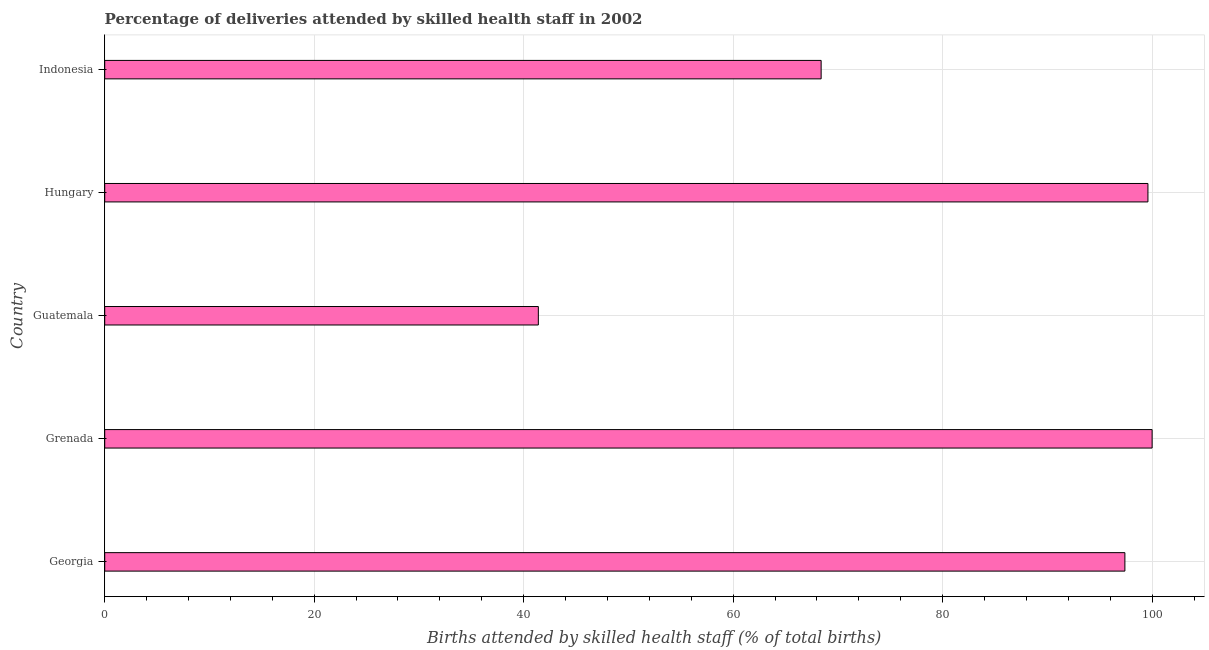Does the graph contain any zero values?
Ensure brevity in your answer.  No. What is the title of the graph?
Provide a succinct answer. Percentage of deliveries attended by skilled health staff in 2002. What is the label or title of the X-axis?
Make the answer very short. Births attended by skilled health staff (% of total births). What is the label or title of the Y-axis?
Provide a short and direct response. Country. What is the number of births attended by skilled health staff in Hungary?
Ensure brevity in your answer.  99.6. Across all countries, what is the maximum number of births attended by skilled health staff?
Offer a terse response. 100. Across all countries, what is the minimum number of births attended by skilled health staff?
Give a very brief answer. 41.4. In which country was the number of births attended by skilled health staff maximum?
Your answer should be compact. Grenada. In which country was the number of births attended by skilled health staff minimum?
Offer a very short reply. Guatemala. What is the sum of the number of births attended by skilled health staff?
Your answer should be compact. 406.8. What is the difference between the number of births attended by skilled health staff in Guatemala and Hungary?
Offer a very short reply. -58.2. What is the average number of births attended by skilled health staff per country?
Make the answer very short. 81.36. What is the median number of births attended by skilled health staff?
Provide a short and direct response. 97.4. In how many countries, is the number of births attended by skilled health staff greater than 28 %?
Provide a succinct answer. 5. What is the ratio of the number of births attended by skilled health staff in Grenada to that in Guatemala?
Ensure brevity in your answer.  2.42. Is the number of births attended by skilled health staff in Georgia less than that in Hungary?
Your response must be concise. Yes. Is the difference between the number of births attended by skilled health staff in Guatemala and Indonesia greater than the difference between any two countries?
Your response must be concise. No. What is the difference between the highest and the second highest number of births attended by skilled health staff?
Ensure brevity in your answer.  0.4. What is the difference between the highest and the lowest number of births attended by skilled health staff?
Provide a short and direct response. 58.6. Are the values on the major ticks of X-axis written in scientific E-notation?
Offer a very short reply. No. What is the Births attended by skilled health staff (% of total births) of Georgia?
Your response must be concise. 97.4. What is the Births attended by skilled health staff (% of total births) of Guatemala?
Make the answer very short. 41.4. What is the Births attended by skilled health staff (% of total births) of Hungary?
Ensure brevity in your answer.  99.6. What is the Births attended by skilled health staff (% of total births) of Indonesia?
Provide a succinct answer. 68.4. What is the difference between the Births attended by skilled health staff (% of total births) in Georgia and Indonesia?
Make the answer very short. 29. What is the difference between the Births attended by skilled health staff (% of total births) in Grenada and Guatemala?
Give a very brief answer. 58.6. What is the difference between the Births attended by skilled health staff (% of total births) in Grenada and Indonesia?
Provide a succinct answer. 31.6. What is the difference between the Births attended by skilled health staff (% of total births) in Guatemala and Hungary?
Give a very brief answer. -58.2. What is the difference between the Births attended by skilled health staff (% of total births) in Guatemala and Indonesia?
Your answer should be compact. -27. What is the difference between the Births attended by skilled health staff (% of total births) in Hungary and Indonesia?
Provide a succinct answer. 31.2. What is the ratio of the Births attended by skilled health staff (% of total births) in Georgia to that in Guatemala?
Make the answer very short. 2.35. What is the ratio of the Births attended by skilled health staff (% of total births) in Georgia to that in Indonesia?
Keep it short and to the point. 1.42. What is the ratio of the Births attended by skilled health staff (% of total births) in Grenada to that in Guatemala?
Make the answer very short. 2.42. What is the ratio of the Births attended by skilled health staff (% of total births) in Grenada to that in Indonesia?
Give a very brief answer. 1.46. What is the ratio of the Births attended by skilled health staff (% of total births) in Guatemala to that in Hungary?
Your response must be concise. 0.42. What is the ratio of the Births attended by skilled health staff (% of total births) in Guatemala to that in Indonesia?
Give a very brief answer. 0.6. What is the ratio of the Births attended by skilled health staff (% of total births) in Hungary to that in Indonesia?
Your answer should be very brief. 1.46. 